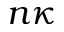Convert formula to latex. <formula><loc_0><loc_0><loc_500><loc_500>n \kappa</formula> 